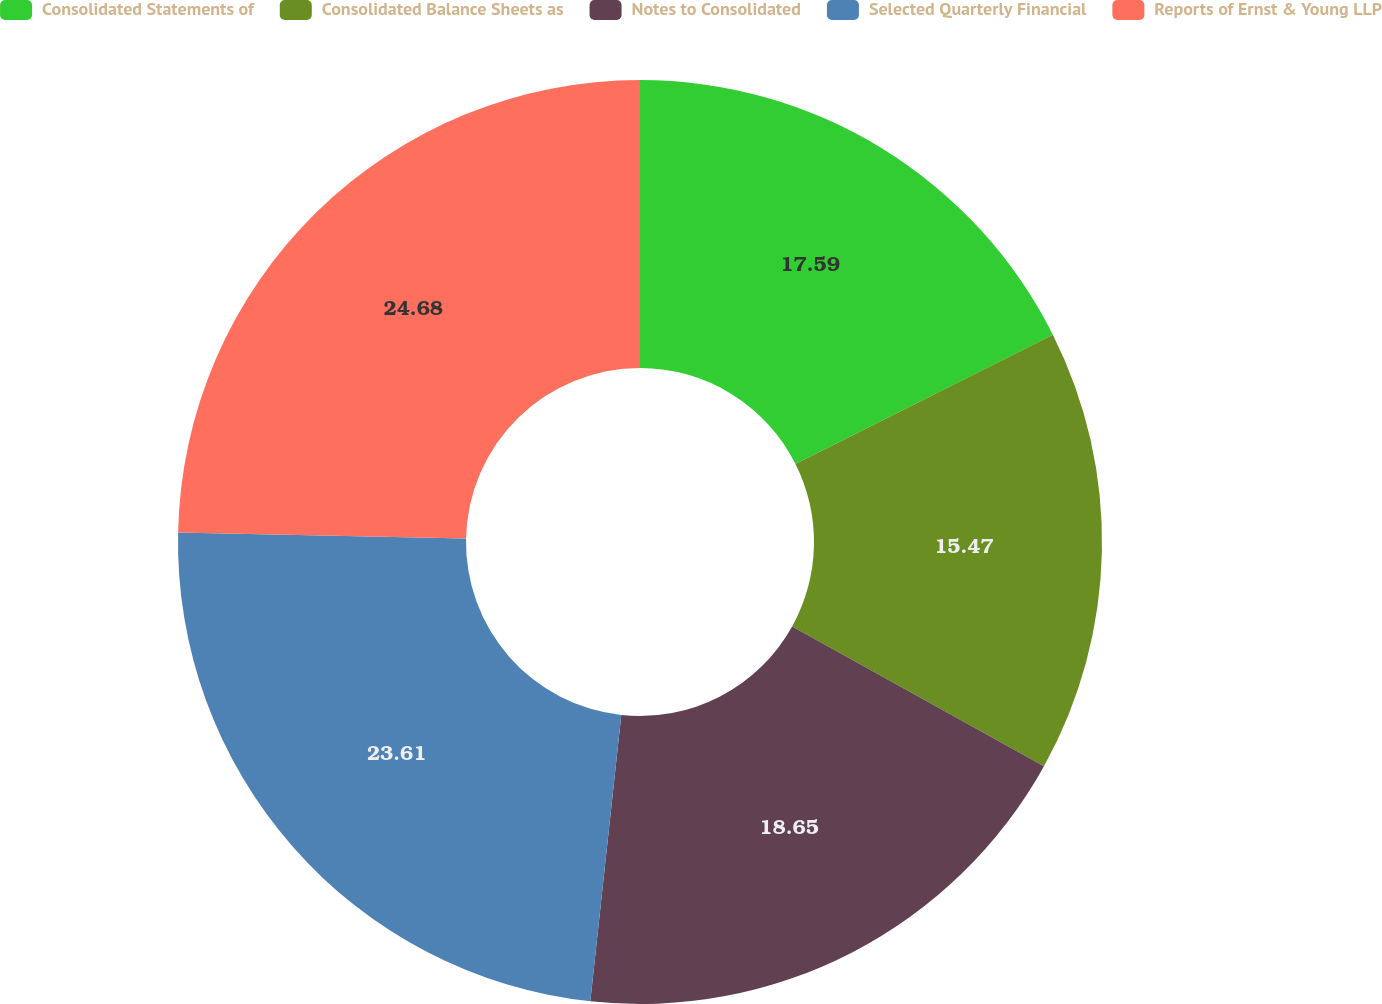<chart> <loc_0><loc_0><loc_500><loc_500><pie_chart><fcel>Consolidated Statements of<fcel>Consolidated Balance Sheets as<fcel>Notes to Consolidated<fcel>Selected Quarterly Financial<fcel>Reports of Ernst & Young LLP<nl><fcel>17.59%<fcel>15.47%<fcel>18.65%<fcel>23.61%<fcel>24.67%<nl></chart> 